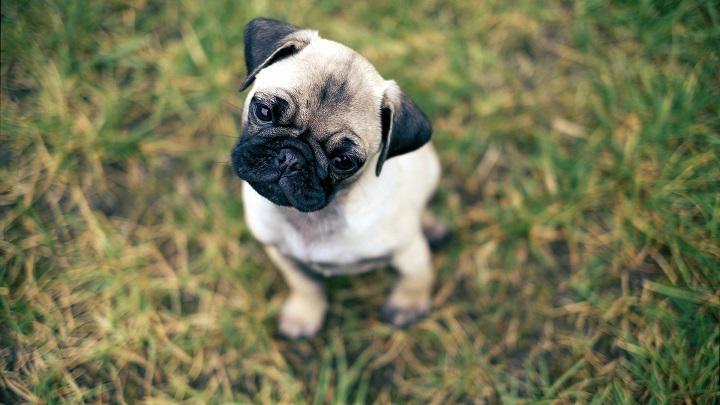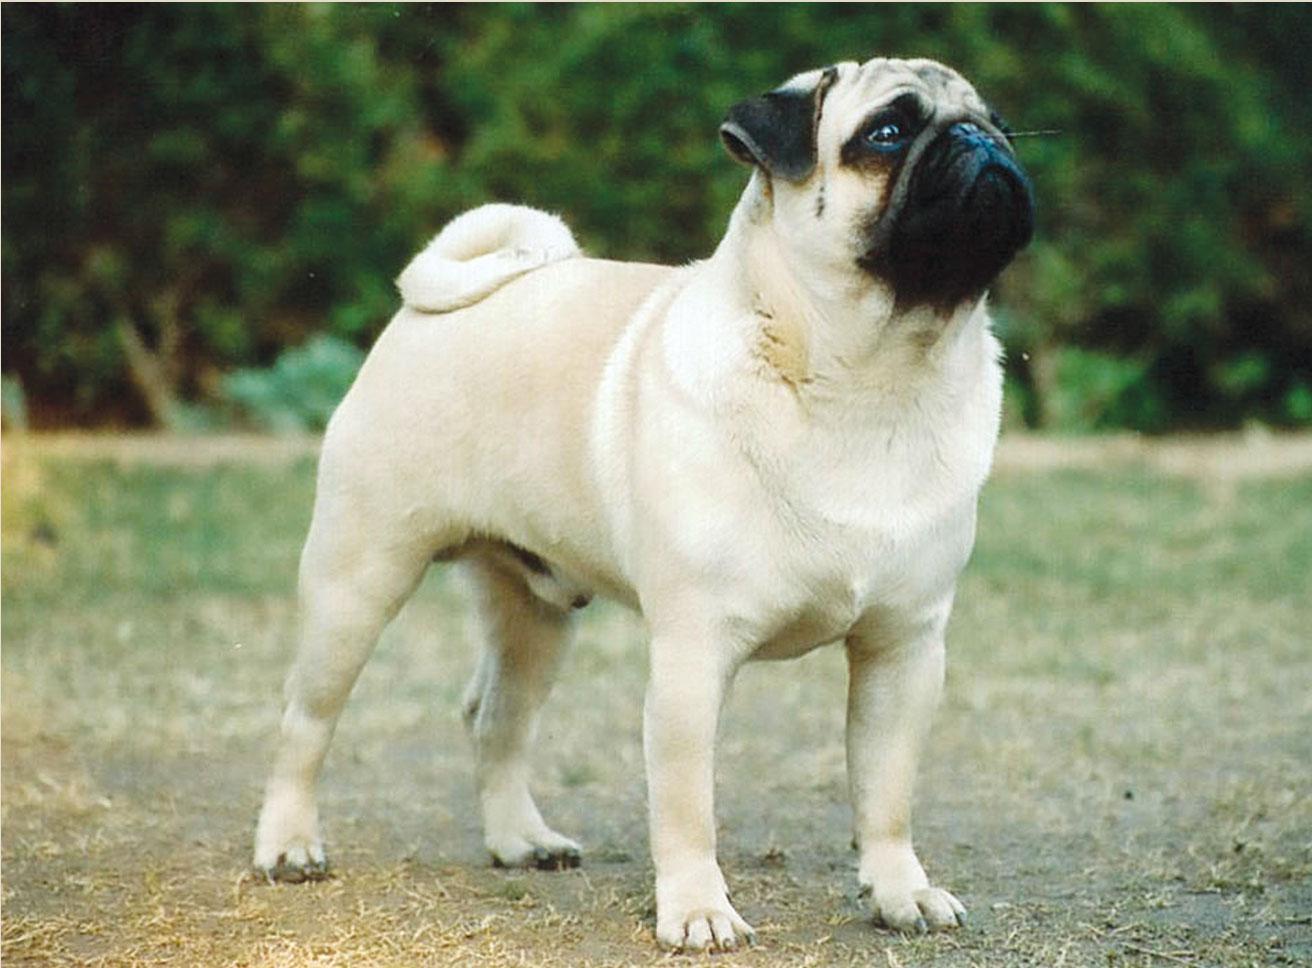The first image is the image on the left, the second image is the image on the right. Examine the images to the left and right. Is the description "Each image shows one dog sitting and one dog standing." accurate? Answer yes or no. Yes. 